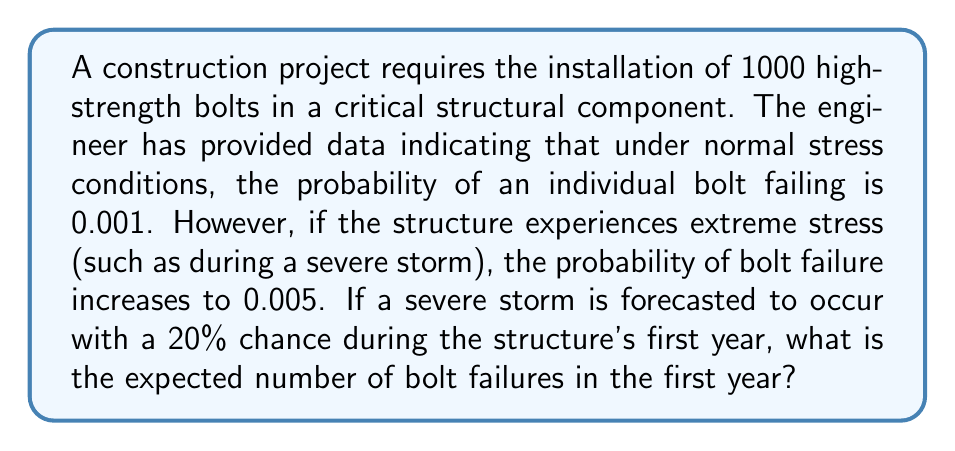Can you answer this question? To solve this problem, we need to use the concept of expected value and the law of total probability. Let's break it down step by step:

1) Let's define our events:
   A: Bolt failure
   S: Severe storm occurs
   N: Normal conditions (no severe storm)

2) We're given the following probabilities:
   $P(A|N) = 0.001$ (probability of bolt failure under normal conditions)
   $P(A|S) = 0.005$ (probability of bolt failure under severe storm conditions)
   $P(S) = 0.2$ (probability of a severe storm occurring)
   $P(N) = 1 - P(S) = 0.8$ (probability of normal conditions)

3) Using the law of total probability, we can calculate the probability of a single bolt failing:

   $$P(A) = P(A|N) \cdot P(N) + P(A|S) \cdot P(S)$$
   $$P(A) = 0.001 \cdot 0.8 + 0.005 \cdot 0.2$$
   $$P(A) = 0.0008 + 0.001 = 0.0018$$

4) Now, to find the expected number of bolt failures, we multiply this probability by the total number of bolts:

   $$E(\text{number of failures}) = 1000 \cdot P(A)$$
   $$E(\text{number of failures}) = 1000 \cdot 0.0018 = 1.8$$

Therefore, the expected number of bolt failures in the first year is 1.8.
Answer: 1.8 bolt failures 